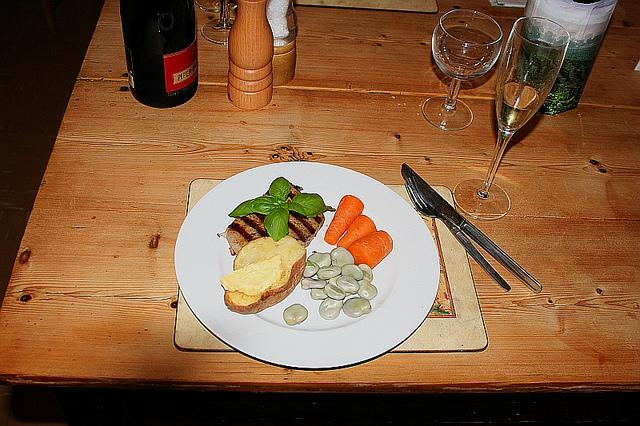What's the meat called?
Write a very short answer. Steak. Is this a balanced meal?
Answer briefly. Yes. What utensils are on the plate?
Short answer required. None. Is the meal a fancy one?
Keep it brief. No. What kind of wine has been poured?
Short answer required. White. Has dinner started yet?
Be succinct. No. Are there any vegetables on the plate?
Keep it brief. Yes. Where are the utensils?
Short answer required. To right of plate. Why is the yellow sauce placed on the side of the sandwich?
Short answer required. Butter. How many knives are depicted?
Be succinct. 1. 